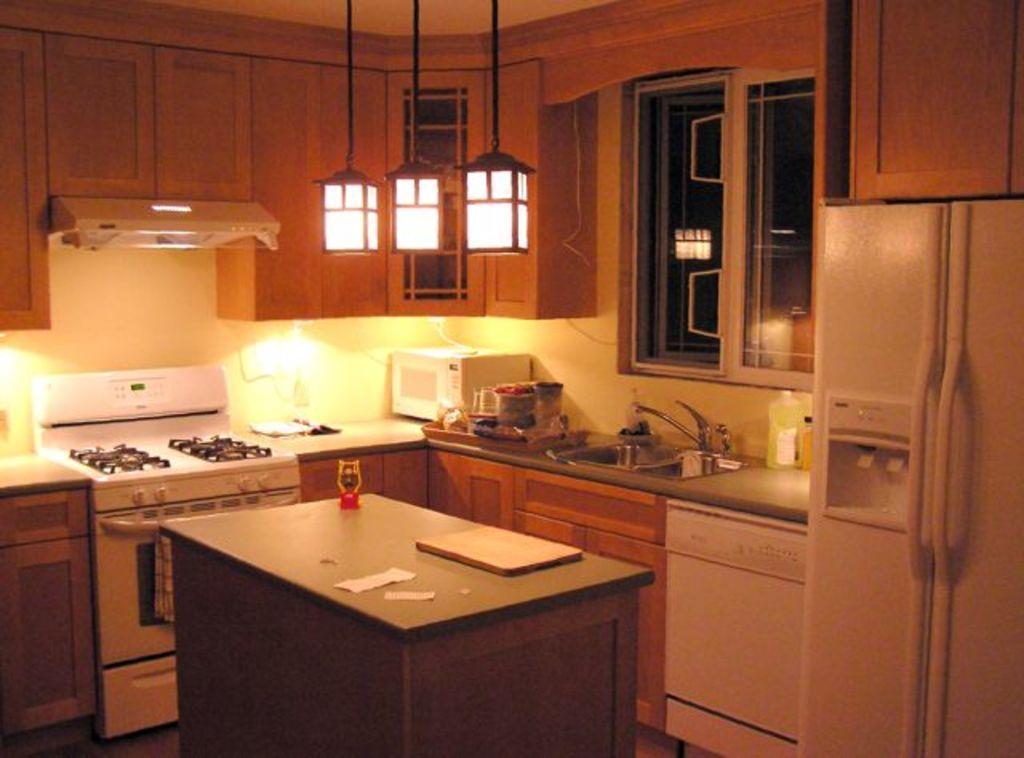How would you summarize this image in a sentence or two? In this image i can see kitchenware,oven,stove,chimney,window and a table. 